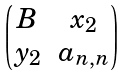Convert formula to latex. <formula><loc_0><loc_0><loc_500><loc_500>\begin{pmatrix} B & x _ { 2 } \\ y _ { 2 } & a _ { n , n } \\ \end{pmatrix}</formula> 